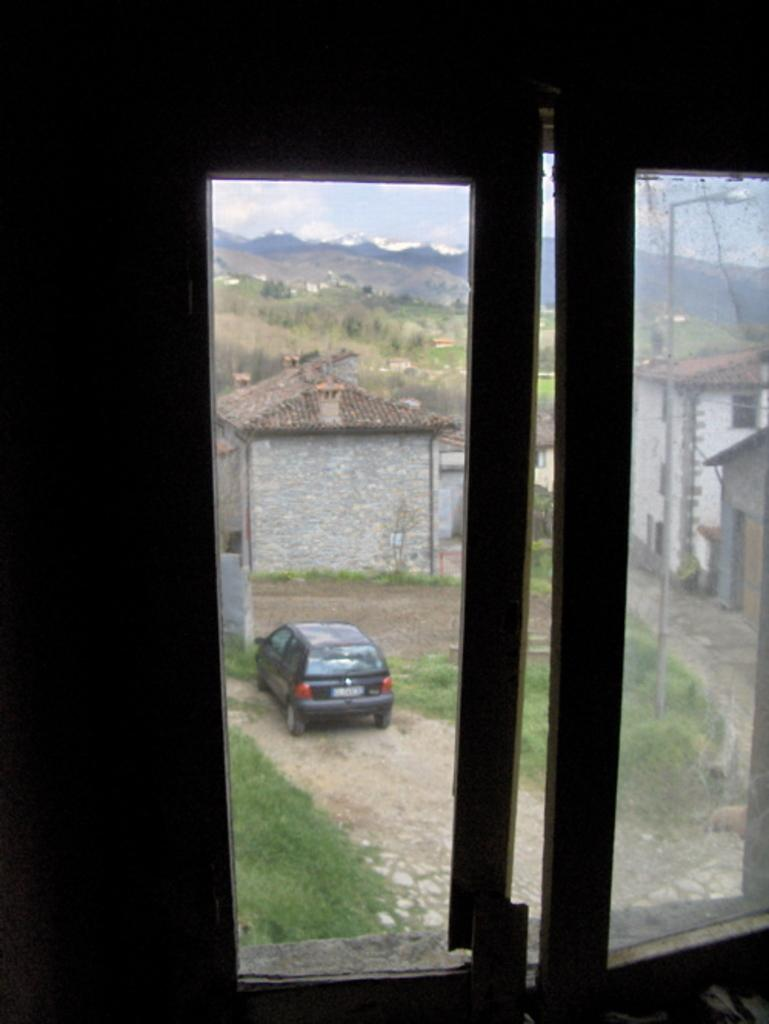What is located in the foreground of the image? There is a window in the foreground of the image. What can be seen in the background of the image? There are mountains, houses, a car, poles, and street lights in the background of the image. Can you describe the natural landscape visible in the image? The natural landscape includes mountains in the background. What type of man-made structures are visible in the image? Houses and street lights are visible in the image. What type of pickle is being used as a doorstop in the image? There is no pickle present in the image, and therefore no such object is being used as a doorstop. 